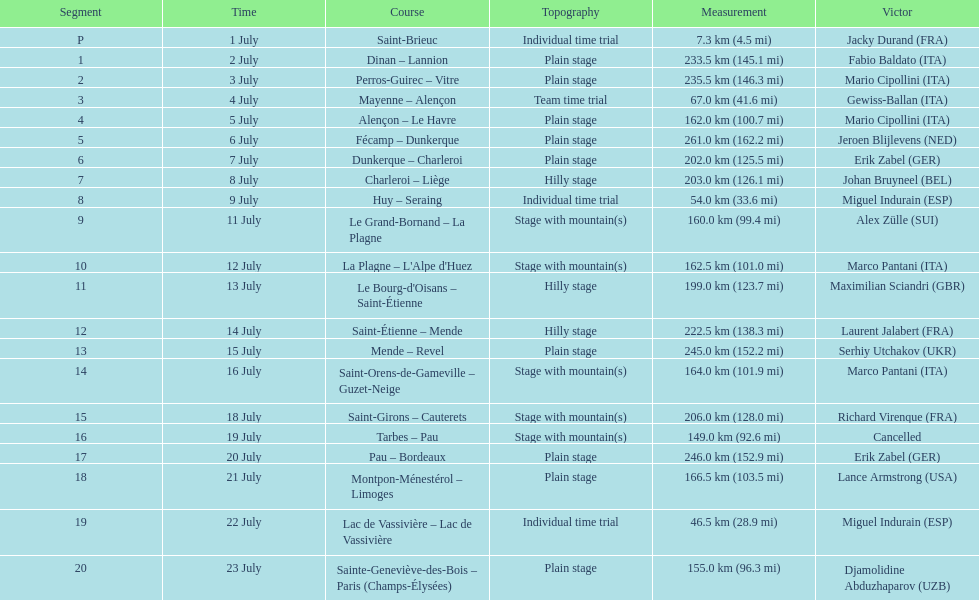How much longer is the 20th tour de france stage than the 19th? 108.5 km. 